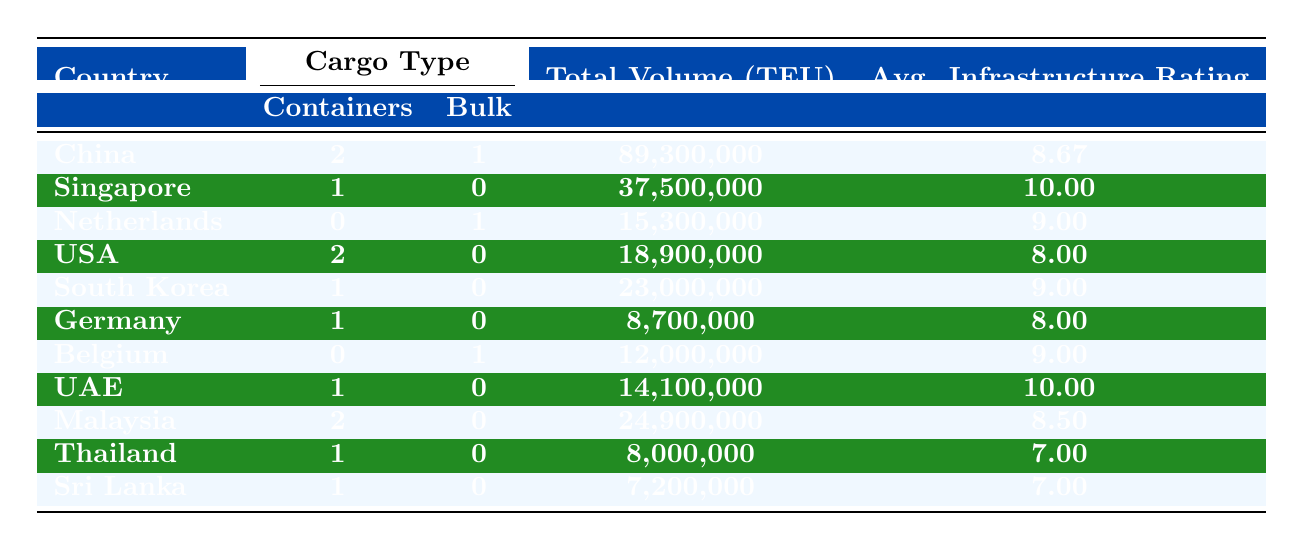What is the total cargo volume in TEU for the Port of Shanghai? The table lists the total volume for the Port of Shanghai under the container cargo type, which is 47,300,000 TEU. This value can be directly retrieved from the volume column corresponding to the Port of Shanghai row.
Answer: 47,300,000 Which country has the highest cargo volume for containers? By examining the total volumes for containers across the countries listed in the table, the Port of Shanghai at 47,300,000 TEU has the highest volume for containers, surpassing Singapore's 37,500,000 TEU. Thus, China has the highest cargo volume for containers.
Answer: China Is the infrastructure rating for the Port of Singapore higher than that for the Port of Hamburg? The infrastructure rating for the Port of Singapore is 10, while the rating for the Port of Hamburg is 8. Since 10 is greater than 8, the statement is true.
Answer: Yes What is the average infrastructure rating for all the ports in Malaysia? There are two ports listed for Malaysia: Port of Klang with an infrastructure rating of 8 and Port of Tanjung Pelepas with a rating of 9. The average is calculated as (8 + 9) / 2 = 8.5.
Answer: 8.5 How much cargo volume in TEU is attributed to bulk cargo from the Netherlands? The table specifies the total volume for bulk cargo from the Netherlands at 15,300,000 TEU. This information can be extracted directly from the bulk cargo column in the Netherlands row.
Answer: 15,300,000 What is the difference in cargo volume (TEU) between the Port of Los Angeles and the Port of Hong Kong? The Port of Los Angeles has a cargo volume of 9,900,000 TEU, while the Port of Hong Kong has a volume of 17,800,000 TEU. The difference is calculated as 17,800,000 - 9,900,000 = 7,900,000 TEU.
Answer: 7,900,000 Does the Port of Antwerp handle more cargo volume than the Port of Hamburg? The Port of Antwerp has a cargo volume of 12,000,000 TEU, while the Port of Hamburg has 8,700,000 TEU. Since 12,000,000 is greater than 8,700,000, this statement is true.
Answer: Yes If you combine the total container volumes of ports in South Korea and the USA, what is the total? The Port of Busan in South Korea has a container volume of 23,000,000 TEU, and the USA has two ports: Port of Los Angeles (9,900,000 TEU) and Port of New York and New Jersey (9,000,000 TEU). Adding these gives a total of 23,000,000 + 9,900,000 + 9,000,000 = 41,900,000 TEU.
Answer: 41,900,000 What is the total number of ports listed for bulk cargo? The table shows that there are three ports handling bulk cargo: Port of Rotterdam, Port of Antwerp, and Port of Guangzhou. Therefore, the total number of ports for bulk cargo is 3.
Answer: 3 